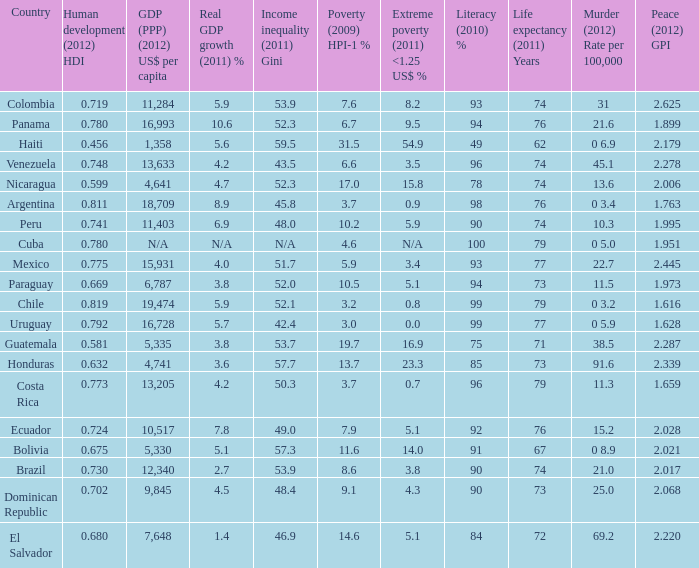What is the total poverty (2009) HPI-1 % when the extreme poverty (2011) <1.25 US$ % of 16.9, and the human development (2012) HDI is less than 0.581? None. 